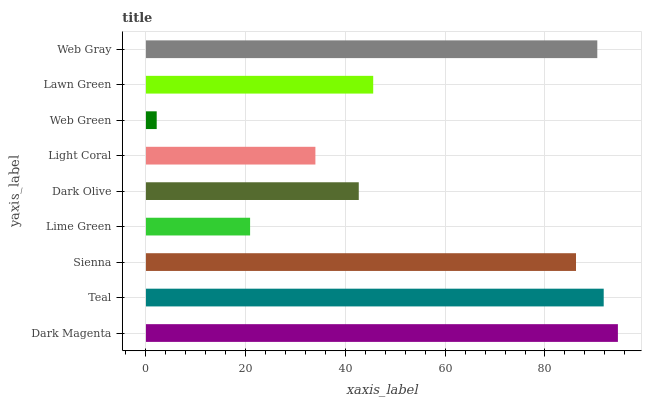Is Web Green the minimum?
Answer yes or no. Yes. Is Dark Magenta the maximum?
Answer yes or no. Yes. Is Teal the minimum?
Answer yes or no. No. Is Teal the maximum?
Answer yes or no. No. Is Dark Magenta greater than Teal?
Answer yes or no. Yes. Is Teal less than Dark Magenta?
Answer yes or no. Yes. Is Teal greater than Dark Magenta?
Answer yes or no. No. Is Dark Magenta less than Teal?
Answer yes or no. No. Is Lawn Green the high median?
Answer yes or no. Yes. Is Lawn Green the low median?
Answer yes or no. Yes. Is Sienna the high median?
Answer yes or no. No. Is Dark Olive the low median?
Answer yes or no. No. 